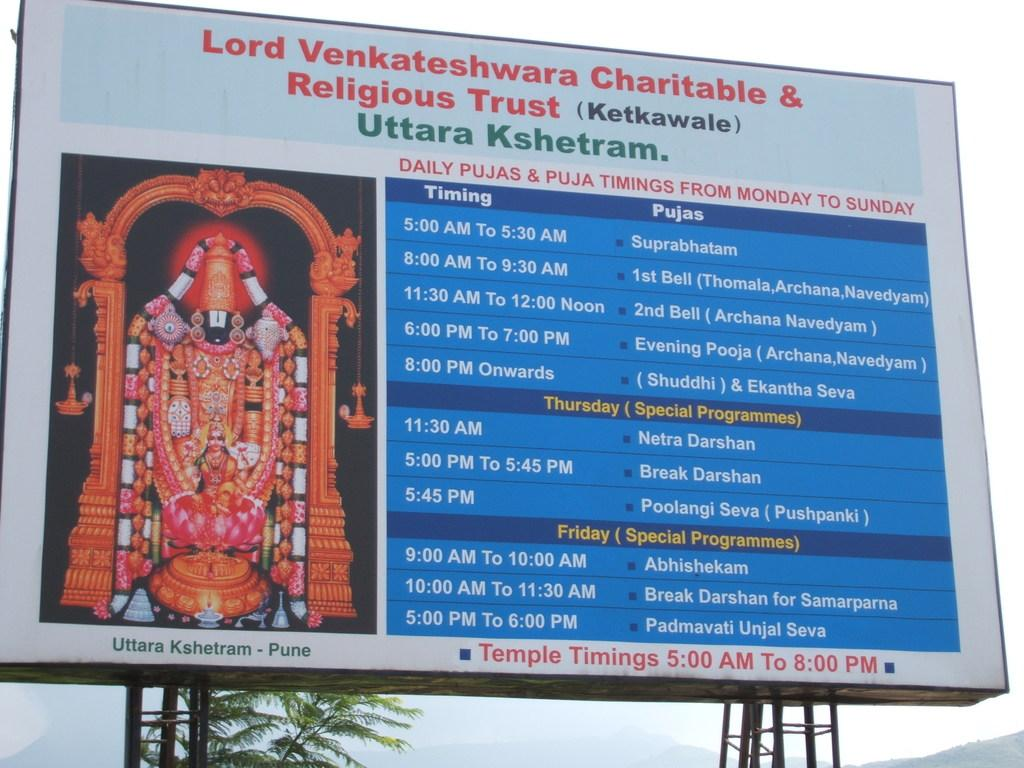<image>
Write a terse but informative summary of the picture. The sign shows times for the charitable and religious trust. 